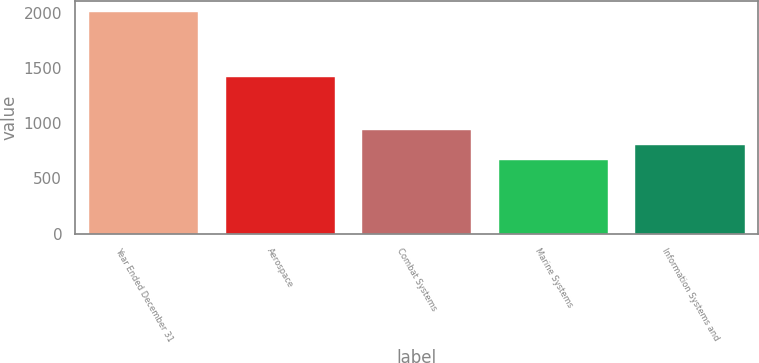Convert chart to OTSL. <chart><loc_0><loc_0><loc_500><loc_500><bar_chart><fcel>Year Ended December 31<fcel>Aerospace<fcel>Combat Systems<fcel>Marine Systems<fcel>Information Systems and<nl><fcel>2013<fcel>1416<fcel>935.4<fcel>666<fcel>800.7<nl></chart> 